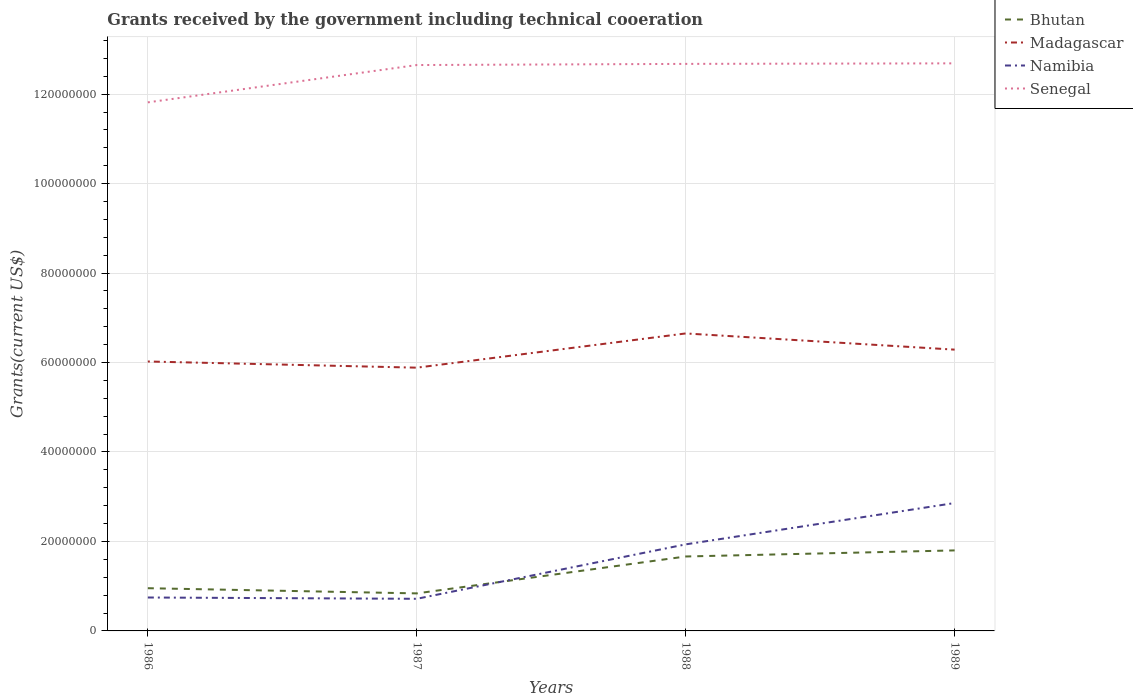How many different coloured lines are there?
Your answer should be compact. 4. Does the line corresponding to Namibia intersect with the line corresponding to Bhutan?
Provide a succinct answer. Yes. Is the number of lines equal to the number of legend labels?
Provide a succinct answer. Yes. Across all years, what is the maximum total grants received by the government in Madagascar?
Make the answer very short. 5.88e+07. In which year was the total grants received by the government in Madagascar maximum?
Your response must be concise. 1987. What is the total total grants received by the government in Bhutan in the graph?
Keep it short and to the point. -8.25e+06. What is the difference between the highest and the second highest total grants received by the government in Senegal?
Your answer should be very brief. 8.72e+06. What is the difference between the highest and the lowest total grants received by the government in Madagascar?
Keep it short and to the point. 2. Is the total grants received by the government in Bhutan strictly greater than the total grants received by the government in Senegal over the years?
Offer a terse response. Yes. How many years are there in the graph?
Make the answer very short. 4. What is the difference between two consecutive major ticks on the Y-axis?
Make the answer very short. 2.00e+07. Are the values on the major ticks of Y-axis written in scientific E-notation?
Your answer should be very brief. No. Where does the legend appear in the graph?
Ensure brevity in your answer.  Top right. How many legend labels are there?
Your response must be concise. 4. What is the title of the graph?
Ensure brevity in your answer.  Grants received by the government including technical cooeration. What is the label or title of the X-axis?
Offer a terse response. Years. What is the label or title of the Y-axis?
Give a very brief answer. Grants(current US$). What is the Grants(current US$) of Bhutan in 1986?
Provide a short and direct response. 9.55e+06. What is the Grants(current US$) of Madagascar in 1986?
Your response must be concise. 6.02e+07. What is the Grants(current US$) of Namibia in 1986?
Provide a succinct answer. 7.47e+06. What is the Grants(current US$) of Senegal in 1986?
Offer a terse response. 1.18e+08. What is the Grants(current US$) in Bhutan in 1987?
Provide a short and direct response. 8.39e+06. What is the Grants(current US$) of Madagascar in 1987?
Give a very brief answer. 5.88e+07. What is the Grants(current US$) of Namibia in 1987?
Your answer should be compact. 7.18e+06. What is the Grants(current US$) in Senegal in 1987?
Keep it short and to the point. 1.26e+08. What is the Grants(current US$) in Bhutan in 1988?
Offer a terse response. 1.66e+07. What is the Grants(current US$) of Madagascar in 1988?
Ensure brevity in your answer.  6.65e+07. What is the Grants(current US$) in Namibia in 1988?
Keep it short and to the point. 1.94e+07. What is the Grants(current US$) in Senegal in 1988?
Ensure brevity in your answer.  1.27e+08. What is the Grants(current US$) of Bhutan in 1989?
Make the answer very short. 1.80e+07. What is the Grants(current US$) in Madagascar in 1989?
Make the answer very short. 6.29e+07. What is the Grants(current US$) in Namibia in 1989?
Your response must be concise. 2.86e+07. What is the Grants(current US$) of Senegal in 1989?
Give a very brief answer. 1.27e+08. Across all years, what is the maximum Grants(current US$) in Bhutan?
Your answer should be very brief. 1.80e+07. Across all years, what is the maximum Grants(current US$) in Madagascar?
Make the answer very short. 6.65e+07. Across all years, what is the maximum Grants(current US$) of Namibia?
Provide a succinct answer. 2.86e+07. Across all years, what is the maximum Grants(current US$) of Senegal?
Offer a terse response. 1.27e+08. Across all years, what is the minimum Grants(current US$) of Bhutan?
Your response must be concise. 8.39e+06. Across all years, what is the minimum Grants(current US$) in Madagascar?
Provide a succinct answer. 5.88e+07. Across all years, what is the minimum Grants(current US$) of Namibia?
Make the answer very short. 7.18e+06. Across all years, what is the minimum Grants(current US$) in Senegal?
Provide a succinct answer. 1.18e+08. What is the total Grants(current US$) in Bhutan in the graph?
Offer a very short reply. 5.26e+07. What is the total Grants(current US$) of Madagascar in the graph?
Your answer should be very brief. 2.48e+08. What is the total Grants(current US$) of Namibia in the graph?
Offer a terse response. 6.26e+07. What is the total Grants(current US$) in Senegal in the graph?
Your answer should be compact. 4.98e+08. What is the difference between the Grants(current US$) in Bhutan in 1986 and that in 1987?
Your answer should be very brief. 1.16e+06. What is the difference between the Grants(current US$) in Madagascar in 1986 and that in 1987?
Your response must be concise. 1.38e+06. What is the difference between the Grants(current US$) in Namibia in 1986 and that in 1987?
Provide a succinct answer. 2.90e+05. What is the difference between the Grants(current US$) in Senegal in 1986 and that in 1987?
Offer a very short reply. -8.34e+06. What is the difference between the Grants(current US$) in Bhutan in 1986 and that in 1988?
Your answer should be very brief. -7.09e+06. What is the difference between the Grants(current US$) in Madagascar in 1986 and that in 1988?
Ensure brevity in your answer.  -6.27e+06. What is the difference between the Grants(current US$) of Namibia in 1986 and that in 1988?
Your answer should be compact. -1.19e+07. What is the difference between the Grants(current US$) in Senegal in 1986 and that in 1988?
Make the answer very short. -8.60e+06. What is the difference between the Grants(current US$) in Bhutan in 1986 and that in 1989?
Provide a short and direct response. -8.45e+06. What is the difference between the Grants(current US$) of Madagascar in 1986 and that in 1989?
Provide a succinct answer. -2.65e+06. What is the difference between the Grants(current US$) in Namibia in 1986 and that in 1989?
Your answer should be very brief. -2.11e+07. What is the difference between the Grants(current US$) of Senegal in 1986 and that in 1989?
Offer a very short reply. -8.72e+06. What is the difference between the Grants(current US$) in Bhutan in 1987 and that in 1988?
Your answer should be compact. -8.25e+06. What is the difference between the Grants(current US$) of Madagascar in 1987 and that in 1988?
Provide a short and direct response. -7.65e+06. What is the difference between the Grants(current US$) in Namibia in 1987 and that in 1988?
Your answer should be compact. -1.22e+07. What is the difference between the Grants(current US$) of Bhutan in 1987 and that in 1989?
Offer a very short reply. -9.61e+06. What is the difference between the Grants(current US$) of Madagascar in 1987 and that in 1989?
Make the answer very short. -4.03e+06. What is the difference between the Grants(current US$) in Namibia in 1987 and that in 1989?
Provide a short and direct response. -2.14e+07. What is the difference between the Grants(current US$) of Senegal in 1987 and that in 1989?
Provide a succinct answer. -3.80e+05. What is the difference between the Grants(current US$) in Bhutan in 1988 and that in 1989?
Make the answer very short. -1.36e+06. What is the difference between the Grants(current US$) in Madagascar in 1988 and that in 1989?
Provide a succinct answer. 3.62e+06. What is the difference between the Grants(current US$) in Namibia in 1988 and that in 1989?
Offer a very short reply. -9.24e+06. What is the difference between the Grants(current US$) in Bhutan in 1986 and the Grants(current US$) in Madagascar in 1987?
Ensure brevity in your answer.  -4.93e+07. What is the difference between the Grants(current US$) in Bhutan in 1986 and the Grants(current US$) in Namibia in 1987?
Ensure brevity in your answer.  2.37e+06. What is the difference between the Grants(current US$) of Bhutan in 1986 and the Grants(current US$) of Senegal in 1987?
Offer a terse response. -1.17e+08. What is the difference between the Grants(current US$) in Madagascar in 1986 and the Grants(current US$) in Namibia in 1987?
Make the answer very short. 5.30e+07. What is the difference between the Grants(current US$) in Madagascar in 1986 and the Grants(current US$) in Senegal in 1987?
Give a very brief answer. -6.63e+07. What is the difference between the Grants(current US$) of Namibia in 1986 and the Grants(current US$) of Senegal in 1987?
Your answer should be compact. -1.19e+08. What is the difference between the Grants(current US$) in Bhutan in 1986 and the Grants(current US$) in Madagascar in 1988?
Keep it short and to the point. -5.70e+07. What is the difference between the Grants(current US$) in Bhutan in 1986 and the Grants(current US$) in Namibia in 1988?
Offer a terse response. -9.80e+06. What is the difference between the Grants(current US$) of Bhutan in 1986 and the Grants(current US$) of Senegal in 1988?
Your answer should be compact. -1.17e+08. What is the difference between the Grants(current US$) of Madagascar in 1986 and the Grants(current US$) of Namibia in 1988?
Provide a short and direct response. 4.09e+07. What is the difference between the Grants(current US$) in Madagascar in 1986 and the Grants(current US$) in Senegal in 1988?
Provide a succinct answer. -6.65e+07. What is the difference between the Grants(current US$) in Namibia in 1986 and the Grants(current US$) in Senegal in 1988?
Your response must be concise. -1.19e+08. What is the difference between the Grants(current US$) of Bhutan in 1986 and the Grants(current US$) of Madagascar in 1989?
Your answer should be compact. -5.33e+07. What is the difference between the Grants(current US$) of Bhutan in 1986 and the Grants(current US$) of Namibia in 1989?
Your answer should be compact. -1.90e+07. What is the difference between the Grants(current US$) of Bhutan in 1986 and the Grants(current US$) of Senegal in 1989?
Make the answer very short. -1.17e+08. What is the difference between the Grants(current US$) in Madagascar in 1986 and the Grants(current US$) in Namibia in 1989?
Provide a short and direct response. 3.16e+07. What is the difference between the Grants(current US$) of Madagascar in 1986 and the Grants(current US$) of Senegal in 1989?
Keep it short and to the point. -6.66e+07. What is the difference between the Grants(current US$) in Namibia in 1986 and the Grants(current US$) in Senegal in 1989?
Ensure brevity in your answer.  -1.19e+08. What is the difference between the Grants(current US$) of Bhutan in 1987 and the Grants(current US$) of Madagascar in 1988?
Your answer should be very brief. -5.81e+07. What is the difference between the Grants(current US$) in Bhutan in 1987 and the Grants(current US$) in Namibia in 1988?
Your response must be concise. -1.10e+07. What is the difference between the Grants(current US$) of Bhutan in 1987 and the Grants(current US$) of Senegal in 1988?
Make the answer very short. -1.18e+08. What is the difference between the Grants(current US$) in Madagascar in 1987 and the Grants(current US$) in Namibia in 1988?
Give a very brief answer. 3.95e+07. What is the difference between the Grants(current US$) of Madagascar in 1987 and the Grants(current US$) of Senegal in 1988?
Provide a succinct answer. -6.79e+07. What is the difference between the Grants(current US$) in Namibia in 1987 and the Grants(current US$) in Senegal in 1988?
Your response must be concise. -1.20e+08. What is the difference between the Grants(current US$) in Bhutan in 1987 and the Grants(current US$) in Madagascar in 1989?
Give a very brief answer. -5.45e+07. What is the difference between the Grants(current US$) of Bhutan in 1987 and the Grants(current US$) of Namibia in 1989?
Provide a succinct answer. -2.02e+07. What is the difference between the Grants(current US$) in Bhutan in 1987 and the Grants(current US$) in Senegal in 1989?
Your answer should be compact. -1.18e+08. What is the difference between the Grants(current US$) in Madagascar in 1987 and the Grants(current US$) in Namibia in 1989?
Offer a terse response. 3.03e+07. What is the difference between the Grants(current US$) in Madagascar in 1987 and the Grants(current US$) in Senegal in 1989?
Provide a succinct answer. -6.80e+07. What is the difference between the Grants(current US$) of Namibia in 1987 and the Grants(current US$) of Senegal in 1989?
Give a very brief answer. -1.20e+08. What is the difference between the Grants(current US$) in Bhutan in 1988 and the Grants(current US$) in Madagascar in 1989?
Your answer should be compact. -4.62e+07. What is the difference between the Grants(current US$) in Bhutan in 1988 and the Grants(current US$) in Namibia in 1989?
Your response must be concise. -1.20e+07. What is the difference between the Grants(current US$) in Bhutan in 1988 and the Grants(current US$) in Senegal in 1989?
Keep it short and to the point. -1.10e+08. What is the difference between the Grants(current US$) of Madagascar in 1988 and the Grants(current US$) of Namibia in 1989?
Your response must be concise. 3.79e+07. What is the difference between the Grants(current US$) in Madagascar in 1988 and the Grants(current US$) in Senegal in 1989?
Keep it short and to the point. -6.04e+07. What is the difference between the Grants(current US$) in Namibia in 1988 and the Grants(current US$) in Senegal in 1989?
Provide a succinct answer. -1.08e+08. What is the average Grants(current US$) of Bhutan per year?
Provide a succinct answer. 1.31e+07. What is the average Grants(current US$) of Madagascar per year?
Your answer should be very brief. 6.21e+07. What is the average Grants(current US$) of Namibia per year?
Provide a succinct answer. 1.56e+07. What is the average Grants(current US$) in Senegal per year?
Ensure brevity in your answer.  1.25e+08. In the year 1986, what is the difference between the Grants(current US$) of Bhutan and Grants(current US$) of Madagascar?
Offer a terse response. -5.07e+07. In the year 1986, what is the difference between the Grants(current US$) of Bhutan and Grants(current US$) of Namibia?
Ensure brevity in your answer.  2.08e+06. In the year 1986, what is the difference between the Grants(current US$) of Bhutan and Grants(current US$) of Senegal?
Your answer should be very brief. -1.09e+08. In the year 1986, what is the difference between the Grants(current US$) of Madagascar and Grants(current US$) of Namibia?
Your answer should be very brief. 5.28e+07. In the year 1986, what is the difference between the Grants(current US$) of Madagascar and Grants(current US$) of Senegal?
Your response must be concise. -5.79e+07. In the year 1986, what is the difference between the Grants(current US$) in Namibia and Grants(current US$) in Senegal?
Offer a terse response. -1.11e+08. In the year 1987, what is the difference between the Grants(current US$) in Bhutan and Grants(current US$) in Madagascar?
Keep it short and to the point. -5.05e+07. In the year 1987, what is the difference between the Grants(current US$) in Bhutan and Grants(current US$) in Namibia?
Provide a short and direct response. 1.21e+06. In the year 1987, what is the difference between the Grants(current US$) of Bhutan and Grants(current US$) of Senegal?
Your answer should be very brief. -1.18e+08. In the year 1987, what is the difference between the Grants(current US$) in Madagascar and Grants(current US$) in Namibia?
Keep it short and to the point. 5.17e+07. In the year 1987, what is the difference between the Grants(current US$) in Madagascar and Grants(current US$) in Senegal?
Provide a short and direct response. -6.76e+07. In the year 1987, what is the difference between the Grants(current US$) in Namibia and Grants(current US$) in Senegal?
Provide a short and direct response. -1.19e+08. In the year 1988, what is the difference between the Grants(current US$) of Bhutan and Grants(current US$) of Madagascar?
Provide a succinct answer. -4.99e+07. In the year 1988, what is the difference between the Grants(current US$) of Bhutan and Grants(current US$) of Namibia?
Ensure brevity in your answer.  -2.71e+06. In the year 1988, what is the difference between the Grants(current US$) of Bhutan and Grants(current US$) of Senegal?
Your response must be concise. -1.10e+08. In the year 1988, what is the difference between the Grants(current US$) of Madagascar and Grants(current US$) of Namibia?
Your answer should be compact. 4.72e+07. In the year 1988, what is the difference between the Grants(current US$) of Madagascar and Grants(current US$) of Senegal?
Make the answer very short. -6.03e+07. In the year 1988, what is the difference between the Grants(current US$) in Namibia and Grants(current US$) in Senegal?
Keep it short and to the point. -1.07e+08. In the year 1989, what is the difference between the Grants(current US$) in Bhutan and Grants(current US$) in Madagascar?
Keep it short and to the point. -4.49e+07. In the year 1989, what is the difference between the Grants(current US$) of Bhutan and Grants(current US$) of Namibia?
Your answer should be very brief. -1.06e+07. In the year 1989, what is the difference between the Grants(current US$) of Bhutan and Grants(current US$) of Senegal?
Ensure brevity in your answer.  -1.09e+08. In the year 1989, what is the difference between the Grants(current US$) of Madagascar and Grants(current US$) of Namibia?
Provide a succinct answer. 3.43e+07. In the year 1989, what is the difference between the Grants(current US$) of Madagascar and Grants(current US$) of Senegal?
Provide a succinct answer. -6.40e+07. In the year 1989, what is the difference between the Grants(current US$) in Namibia and Grants(current US$) in Senegal?
Give a very brief answer. -9.83e+07. What is the ratio of the Grants(current US$) in Bhutan in 1986 to that in 1987?
Make the answer very short. 1.14. What is the ratio of the Grants(current US$) of Madagascar in 1986 to that in 1987?
Make the answer very short. 1.02. What is the ratio of the Grants(current US$) of Namibia in 1986 to that in 1987?
Provide a succinct answer. 1.04. What is the ratio of the Grants(current US$) in Senegal in 1986 to that in 1987?
Give a very brief answer. 0.93. What is the ratio of the Grants(current US$) of Bhutan in 1986 to that in 1988?
Your response must be concise. 0.57. What is the ratio of the Grants(current US$) in Madagascar in 1986 to that in 1988?
Your answer should be compact. 0.91. What is the ratio of the Grants(current US$) in Namibia in 1986 to that in 1988?
Ensure brevity in your answer.  0.39. What is the ratio of the Grants(current US$) in Senegal in 1986 to that in 1988?
Give a very brief answer. 0.93. What is the ratio of the Grants(current US$) of Bhutan in 1986 to that in 1989?
Your answer should be compact. 0.53. What is the ratio of the Grants(current US$) in Madagascar in 1986 to that in 1989?
Make the answer very short. 0.96. What is the ratio of the Grants(current US$) of Namibia in 1986 to that in 1989?
Keep it short and to the point. 0.26. What is the ratio of the Grants(current US$) of Senegal in 1986 to that in 1989?
Offer a very short reply. 0.93. What is the ratio of the Grants(current US$) in Bhutan in 1987 to that in 1988?
Offer a terse response. 0.5. What is the ratio of the Grants(current US$) in Madagascar in 1987 to that in 1988?
Make the answer very short. 0.89. What is the ratio of the Grants(current US$) of Namibia in 1987 to that in 1988?
Your answer should be compact. 0.37. What is the ratio of the Grants(current US$) of Senegal in 1987 to that in 1988?
Provide a succinct answer. 1. What is the ratio of the Grants(current US$) in Bhutan in 1987 to that in 1989?
Ensure brevity in your answer.  0.47. What is the ratio of the Grants(current US$) of Madagascar in 1987 to that in 1989?
Ensure brevity in your answer.  0.94. What is the ratio of the Grants(current US$) of Namibia in 1987 to that in 1989?
Offer a very short reply. 0.25. What is the ratio of the Grants(current US$) of Bhutan in 1988 to that in 1989?
Ensure brevity in your answer.  0.92. What is the ratio of the Grants(current US$) in Madagascar in 1988 to that in 1989?
Ensure brevity in your answer.  1.06. What is the ratio of the Grants(current US$) of Namibia in 1988 to that in 1989?
Give a very brief answer. 0.68. What is the ratio of the Grants(current US$) in Senegal in 1988 to that in 1989?
Provide a succinct answer. 1. What is the difference between the highest and the second highest Grants(current US$) in Bhutan?
Offer a very short reply. 1.36e+06. What is the difference between the highest and the second highest Grants(current US$) of Madagascar?
Your answer should be compact. 3.62e+06. What is the difference between the highest and the second highest Grants(current US$) of Namibia?
Ensure brevity in your answer.  9.24e+06. What is the difference between the highest and the second highest Grants(current US$) in Senegal?
Your response must be concise. 1.20e+05. What is the difference between the highest and the lowest Grants(current US$) of Bhutan?
Give a very brief answer. 9.61e+06. What is the difference between the highest and the lowest Grants(current US$) in Madagascar?
Keep it short and to the point. 7.65e+06. What is the difference between the highest and the lowest Grants(current US$) of Namibia?
Offer a terse response. 2.14e+07. What is the difference between the highest and the lowest Grants(current US$) in Senegal?
Offer a very short reply. 8.72e+06. 